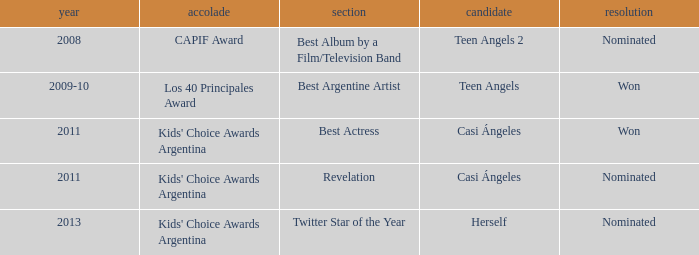What year saw an award in the category of Revelation? 2011.0. 